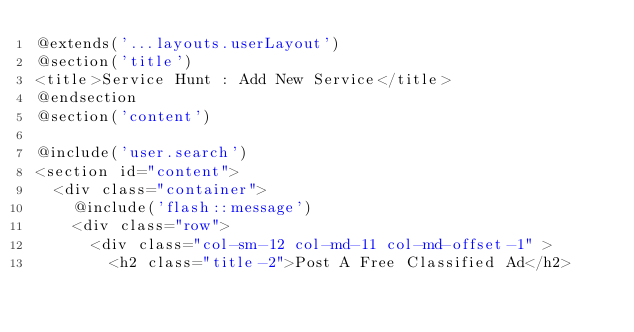<code> <loc_0><loc_0><loc_500><loc_500><_PHP_>@extends('...layouts.userLayout')
@section('title')
<title>Service Hunt : Add New Service</title>
@endsection
@section('content')

@include('user.search')
<section id="content">
  <div class="container">
    @include('flash::message')
    <div class="row">
      <div class="col-sm-12 col-md-11 col-md-offset-1" >
        <h2 class="title-2">Post A Free Classified Ad</h2></code> 